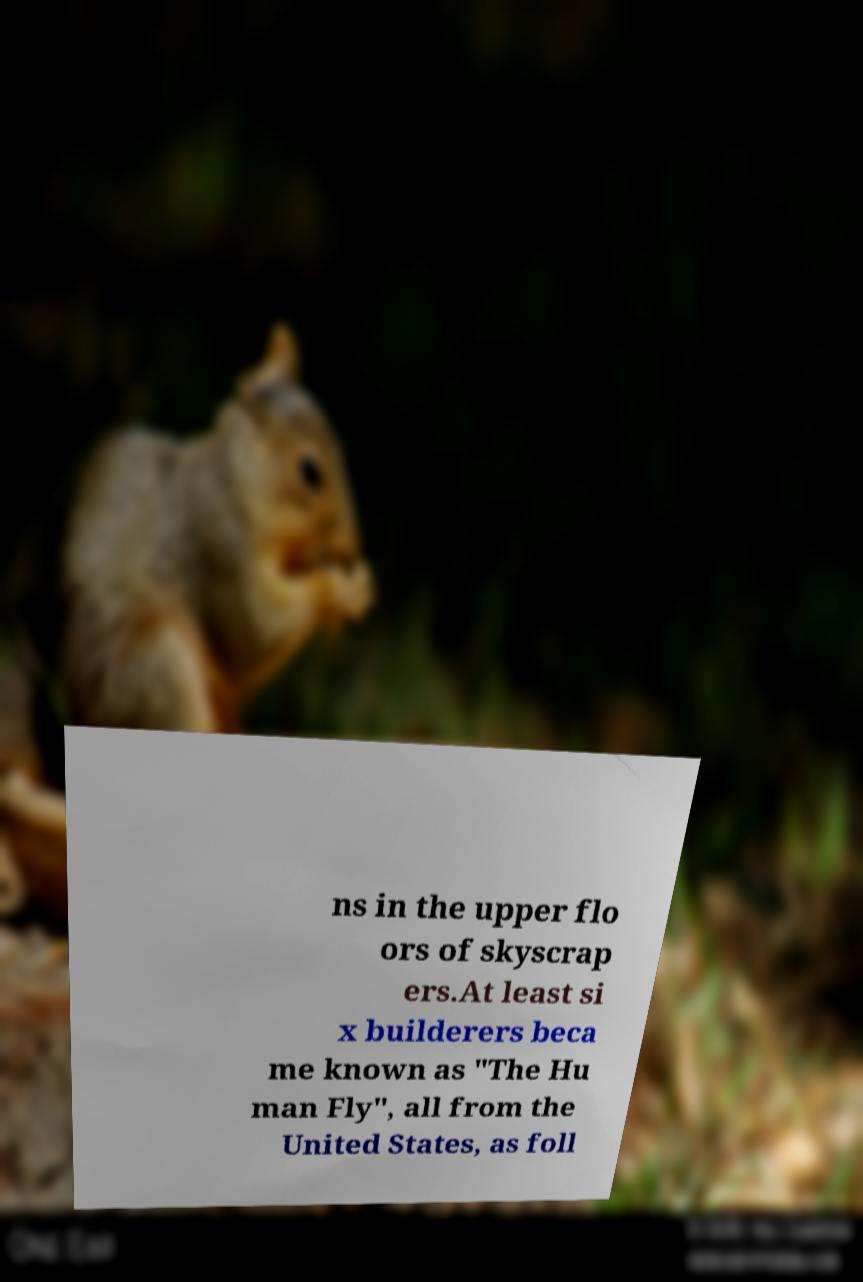Can you read and provide the text displayed in the image?This photo seems to have some interesting text. Can you extract and type it out for me? ns in the upper flo ors of skyscrap ers.At least si x builderers beca me known as "The Hu man Fly", all from the United States, as foll 